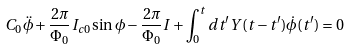Convert formula to latex. <formula><loc_0><loc_0><loc_500><loc_500>C _ { 0 } \ddot { \phi } + \frac { 2 \pi } { \Phi _ { 0 } } I _ { c 0 } \sin \phi - \frac { 2 \pi } { \Phi _ { 0 } } I + \int _ { 0 } ^ { t } d t ^ { \prime } Y ( t - t ^ { \prime } ) \dot { \phi } ( t ^ { \prime } ) = 0</formula> 